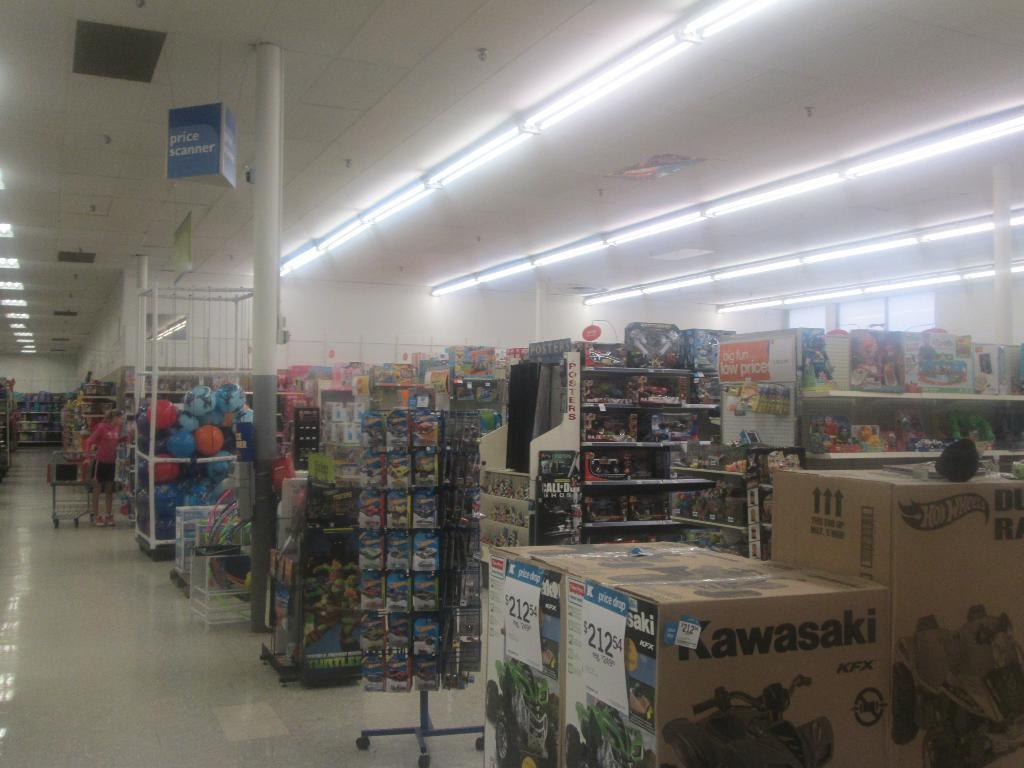Provide a one-sentence caption for the provided image. A store with lots of toy and a Kawasaki car toy. 